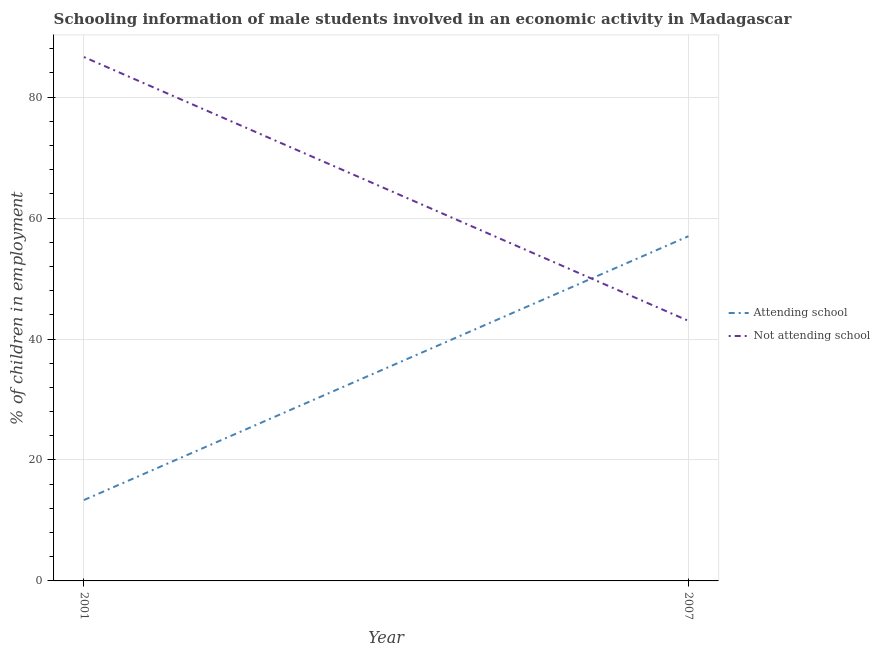Is the number of lines equal to the number of legend labels?
Keep it short and to the point. Yes. What is the percentage of employed males who are not attending school in 2001?
Offer a very short reply. 86.63. Across all years, what is the maximum percentage of employed males who are not attending school?
Provide a short and direct response. 86.63. In which year was the percentage of employed males who are attending school maximum?
Offer a terse response. 2007. What is the total percentage of employed males who are not attending school in the graph?
Give a very brief answer. 129.63. What is the difference between the percentage of employed males who are not attending school in 2001 and that in 2007?
Your answer should be very brief. 43.63. What is the difference between the percentage of employed males who are not attending school in 2001 and the percentage of employed males who are attending school in 2007?
Your response must be concise. 29.63. What is the average percentage of employed males who are attending school per year?
Your answer should be very brief. 35.19. In the year 2001, what is the difference between the percentage of employed males who are attending school and percentage of employed males who are not attending school?
Provide a short and direct response. -73.26. What is the ratio of the percentage of employed males who are not attending school in 2001 to that in 2007?
Offer a terse response. 2.01. In how many years, is the percentage of employed males who are attending school greater than the average percentage of employed males who are attending school taken over all years?
Ensure brevity in your answer.  1. Is the percentage of employed males who are attending school strictly greater than the percentage of employed males who are not attending school over the years?
Ensure brevity in your answer.  No. Is the percentage of employed males who are attending school strictly less than the percentage of employed males who are not attending school over the years?
Your response must be concise. No. How many lines are there?
Your answer should be compact. 2. How many years are there in the graph?
Offer a terse response. 2. What is the difference between two consecutive major ticks on the Y-axis?
Keep it short and to the point. 20. Are the values on the major ticks of Y-axis written in scientific E-notation?
Give a very brief answer. No. Does the graph contain any zero values?
Keep it short and to the point. No. Does the graph contain grids?
Your answer should be compact. Yes. Where does the legend appear in the graph?
Give a very brief answer. Center right. How are the legend labels stacked?
Your answer should be very brief. Vertical. What is the title of the graph?
Provide a short and direct response. Schooling information of male students involved in an economic activity in Madagascar. Does "Male labor force" appear as one of the legend labels in the graph?
Give a very brief answer. No. What is the label or title of the X-axis?
Offer a terse response. Year. What is the label or title of the Y-axis?
Provide a succinct answer. % of children in employment. What is the % of children in employment of Attending school in 2001?
Give a very brief answer. 13.37. What is the % of children in employment in Not attending school in 2001?
Provide a short and direct response. 86.63. What is the % of children in employment of Attending school in 2007?
Provide a succinct answer. 57. What is the % of children in employment in Not attending school in 2007?
Make the answer very short. 43. Across all years, what is the maximum % of children in employment of Not attending school?
Give a very brief answer. 86.63. Across all years, what is the minimum % of children in employment of Attending school?
Your answer should be compact. 13.37. Across all years, what is the minimum % of children in employment of Not attending school?
Ensure brevity in your answer.  43. What is the total % of children in employment in Attending school in the graph?
Provide a succinct answer. 70.37. What is the total % of children in employment of Not attending school in the graph?
Keep it short and to the point. 129.63. What is the difference between the % of children in employment of Attending school in 2001 and that in 2007?
Provide a succinct answer. -43.63. What is the difference between the % of children in employment in Not attending school in 2001 and that in 2007?
Keep it short and to the point. 43.63. What is the difference between the % of children in employment in Attending school in 2001 and the % of children in employment in Not attending school in 2007?
Provide a succinct answer. -29.63. What is the average % of children in employment in Attending school per year?
Keep it short and to the point. 35.19. What is the average % of children in employment of Not attending school per year?
Offer a terse response. 64.81. In the year 2001, what is the difference between the % of children in employment in Attending school and % of children in employment in Not attending school?
Provide a succinct answer. -73.26. In the year 2007, what is the difference between the % of children in employment in Attending school and % of children in employment in Not attending school?
Provide a succinct answer. 14. What is the ratio of the % of children in employment in Attending school in 2001 to that in 2007?
Keep it short and to the point. 0.23. What is the ratio of the % of children in employment of Not attending school in 2001 to that in 2007?
Keep it short and to the point. 2.01. What is the difference between the highest and the second highest % of children in employment in Attending school?
Provide a short and direct response. 43.63. What is the difference between the highest and the second highest % of children in employment of Not attending school?
Ensure brevity in your answer.  43.63. What is the difference between the highest and the lowest % of children in employment of Attending school?
Ensure brevity in your answer.  43.63. What is the difference between the highest and the lowest % of children in employment of Not attending school?
Make the answer very short. 43.63. 